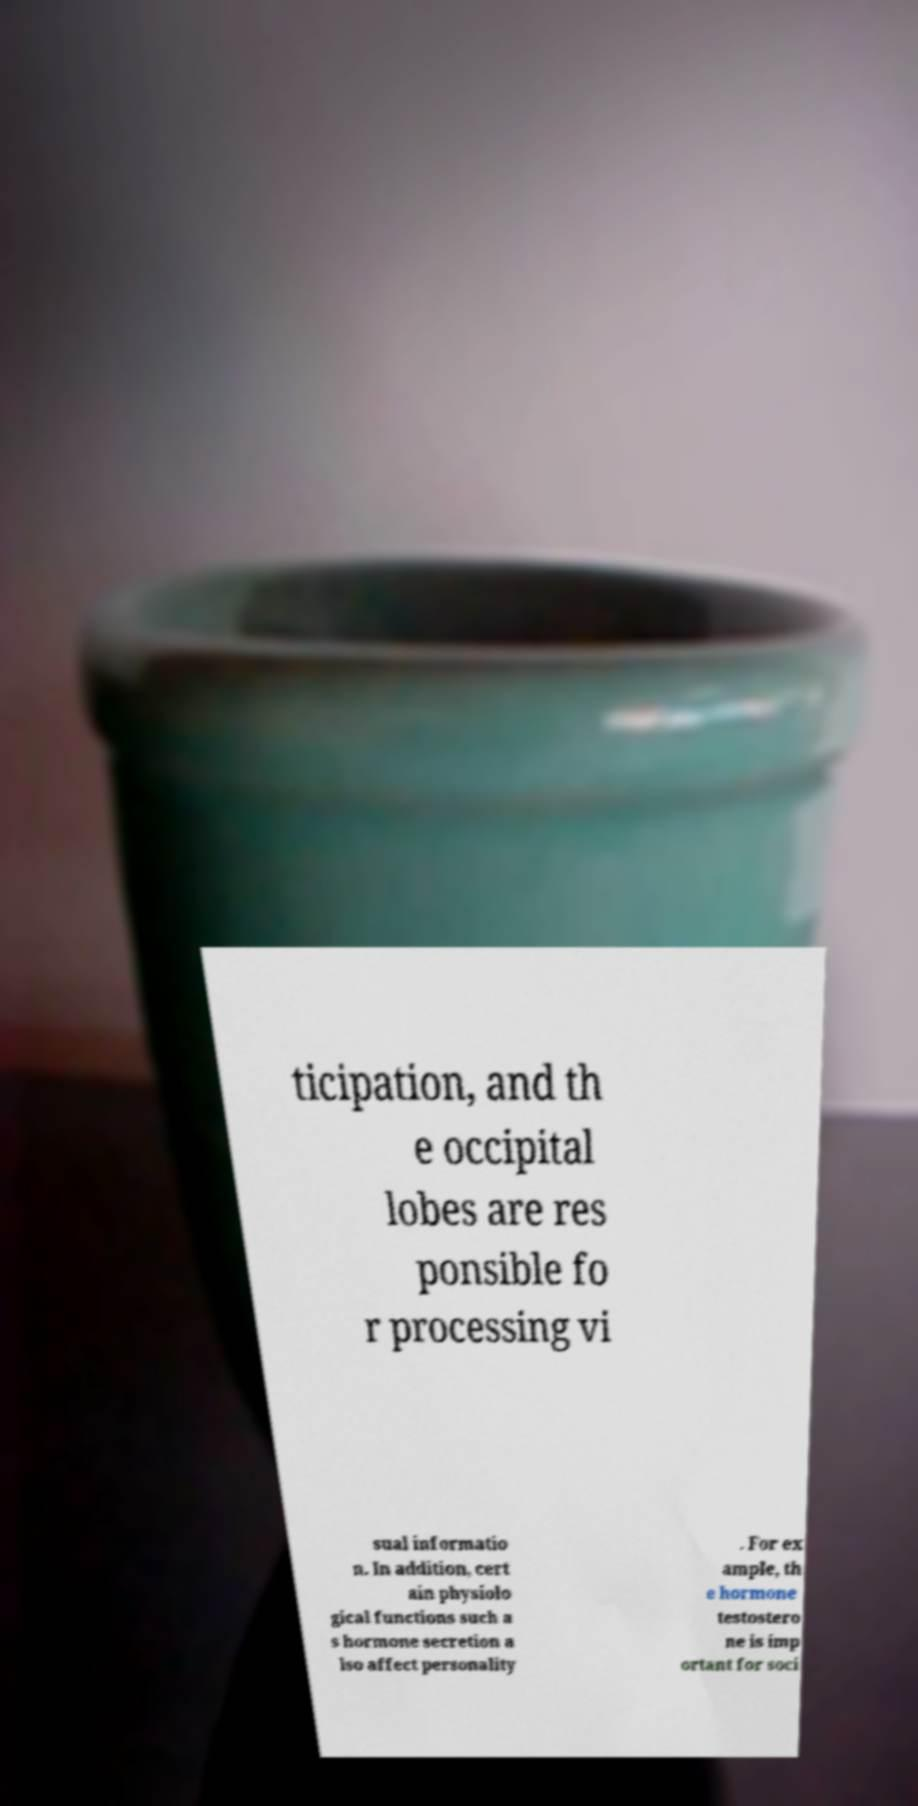What messages or text are displayed in this image? I need them in a readable, typed format. ticipation, and th e occipital lobes are res ponsible fo r processing vi sual informatio n. In addition, cert ain physiolo gical functions such a s hormone secretion a lso affect personality . For ex ample, th e hormone testostero ne is imp ortant for soci 